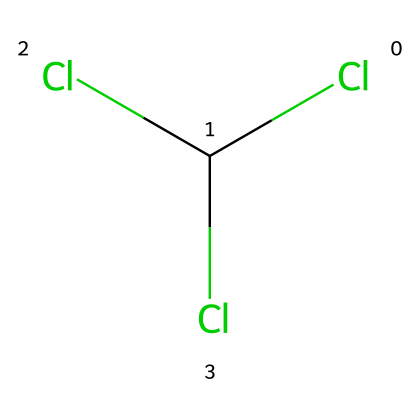What is the molecular formula of chloroform? The structure shows three chlorine atoms and one carbon atom bonded to each other, which indicates the presence of these elements in the compound. The composed formula from the structure is CCl3H.
Answer: CCl3H How many chlorine atoms are in the molecule? The SMILES notation shows 'Cl' repeated three times, indicating there are three chlorine atoms bonded to the central carbon atom.
Answer: three What is the primary functional group of chloroform? By examining the structure, chloroform lacks a hydroxyl group, indicating that its primary functional group is a haloalkane (due to the presence of halogen atoms).
Answer: haloalkane Does chloroform have any hydrogen atoms? The structure reveals that, besides the carbon and chlorine atoms, there is one hydrogen atom bonded to the carbon atom, showing that it indeed has hydrogen in its composition.
Answer: one What historical use did chloroform have in medicine? Chloroform was historically used as an anesthetic during surgeries, primarily to induce unconsciousness in patients.
Answer: anesthetic What ethical concerns arose from the historical use of chloroform? The use of chloroform as an anesthetic raised concerns regarding its safety, potential for overdose, and the ethical implications of its use in surgery without full understanding of its effects on patients.
Answer: safety and ethics 